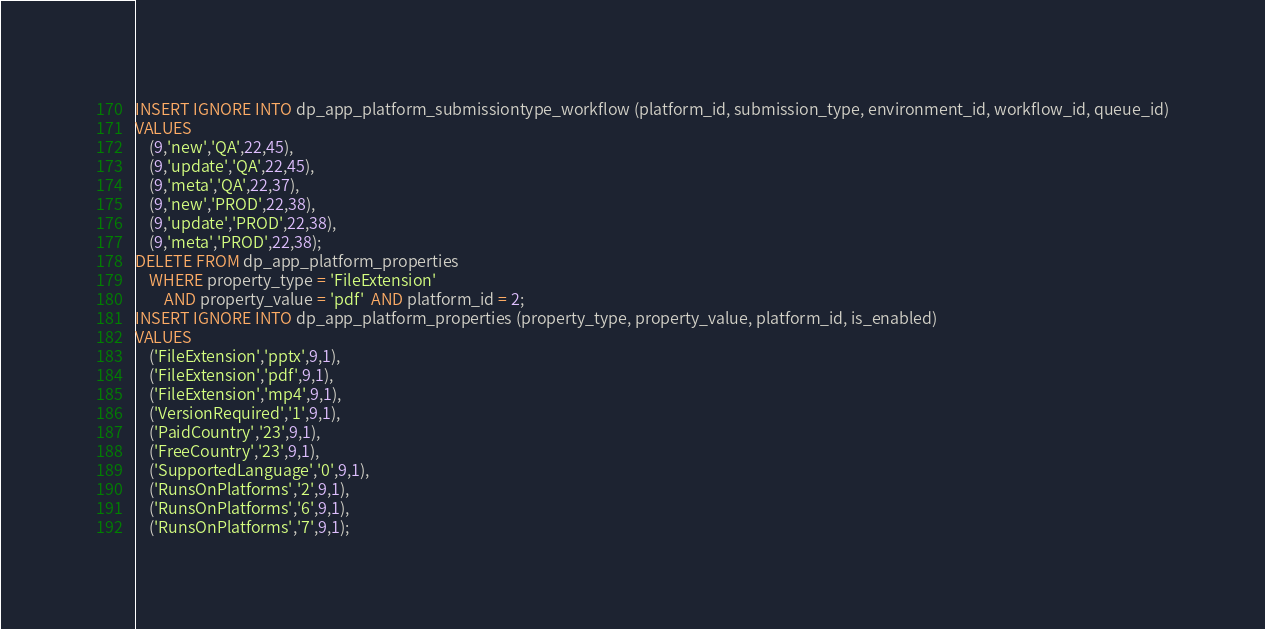<code> <loc_0><loc_0><loc_500><loc_500><_SQL_>INSERT IGNORE INTO dp_app_platform_submissiontype_workflow (platform_id, submission_type, environment_id, workflow_id, queue_id)
VALUES
    (9,'new','QA',22,45),
    (9,'update','QA',22,45),
    (9,'meta','QA',22,37),
    (9,'new','PROD',22,38),
    (9,'update','PROD',22,38),
    (9,'meta','PROD',22,38);
DELETE FROM dp_app_platform_properties  
    WHERE property_type = 'FileExtension' 
        AND property_value = 'pdf'  AND platform_id = 2;
INSERT IGNORE INTO dp_app_platform_properties (property_type, property_value, platform_id, is_enabled)
VALUES
    ('FileExtension','pptx',9,1),
    ('FileExtension','pdf',9,1),
    ('FileExtension','mp4',9,1),
    ('VersionRequired','1',9,1),
    ('PaidCountry','23',9,1),
    ('FreeCountry','23',9,1),
    ('SupportedLanguage','0',9,1),
    ('RunsOnPlatforms','2',9,1),
    ('RunsOnPlatforms','6',9,1),
    ('RunsOnPlatforms','7',9,1);</code> 